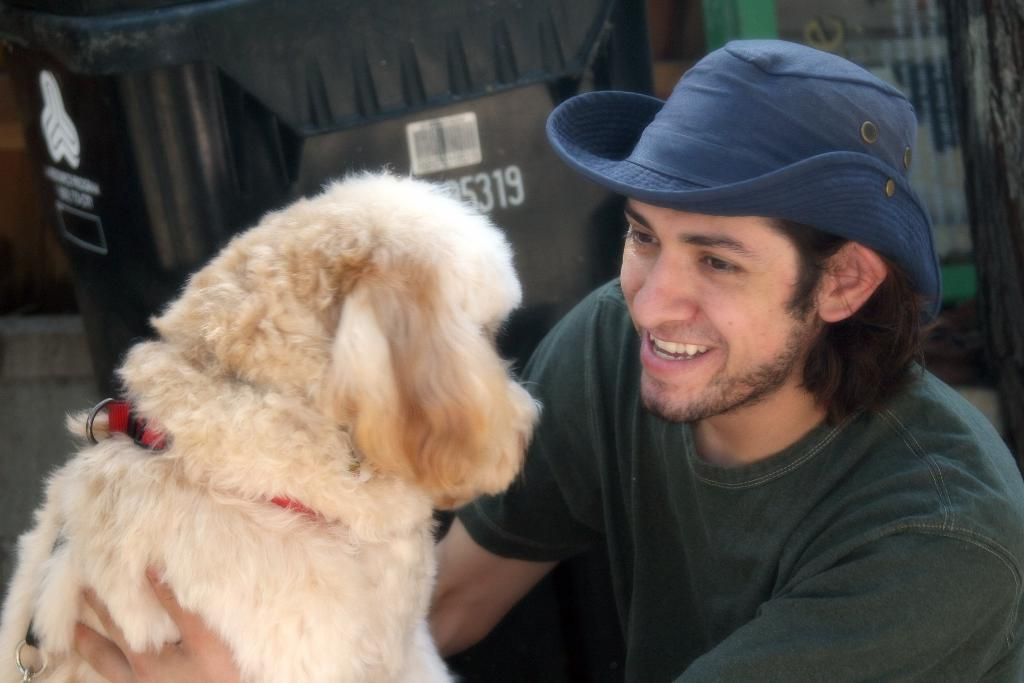What is the man in the image doing? The man is catching a dog in the image. What is the man's facial expression? The man is smiling in the image. What is the man wearing on his head? The man is wearing a hat in the image. What color is the man's hat? The hat is blue in color. What can be seen in the background of the image? There is a television in the background of the image. What is the position of the television in the image? The television is turned around in the image. What type of vessel is being used for the bath in the image? There is no vessel or bath present in the image; it features a man catching a dog. What type of furniture is visible in the image? The provided facts do not mention any furniture in the image. 